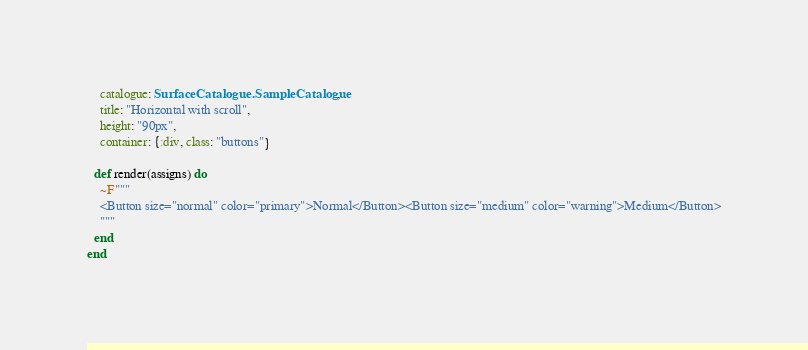Convert code to text. <code><loc_0><loc_0><loc_500><loc_500><_Elixir_>    catalogue: SurfaceCatalogue.SampleCatalogue,
    title: "Horizontal with scroll",
    height: "90px",
    container: {:div, class: "buttons"}

  def render(assigns) do
    ~F"""
    <Button size="normal" color="primary">Normal</Button><Button size="medium" color="warning">Medium</Button>
    """
  end
end
</code> 